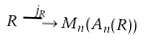Convert formula to latex. <formula><loc_0><loc_0><loc_500><loc_500>R \stackrel { j _ { R } } \longrightarrow M _ { n } ( A _ { n } ( R ) )</formula> 